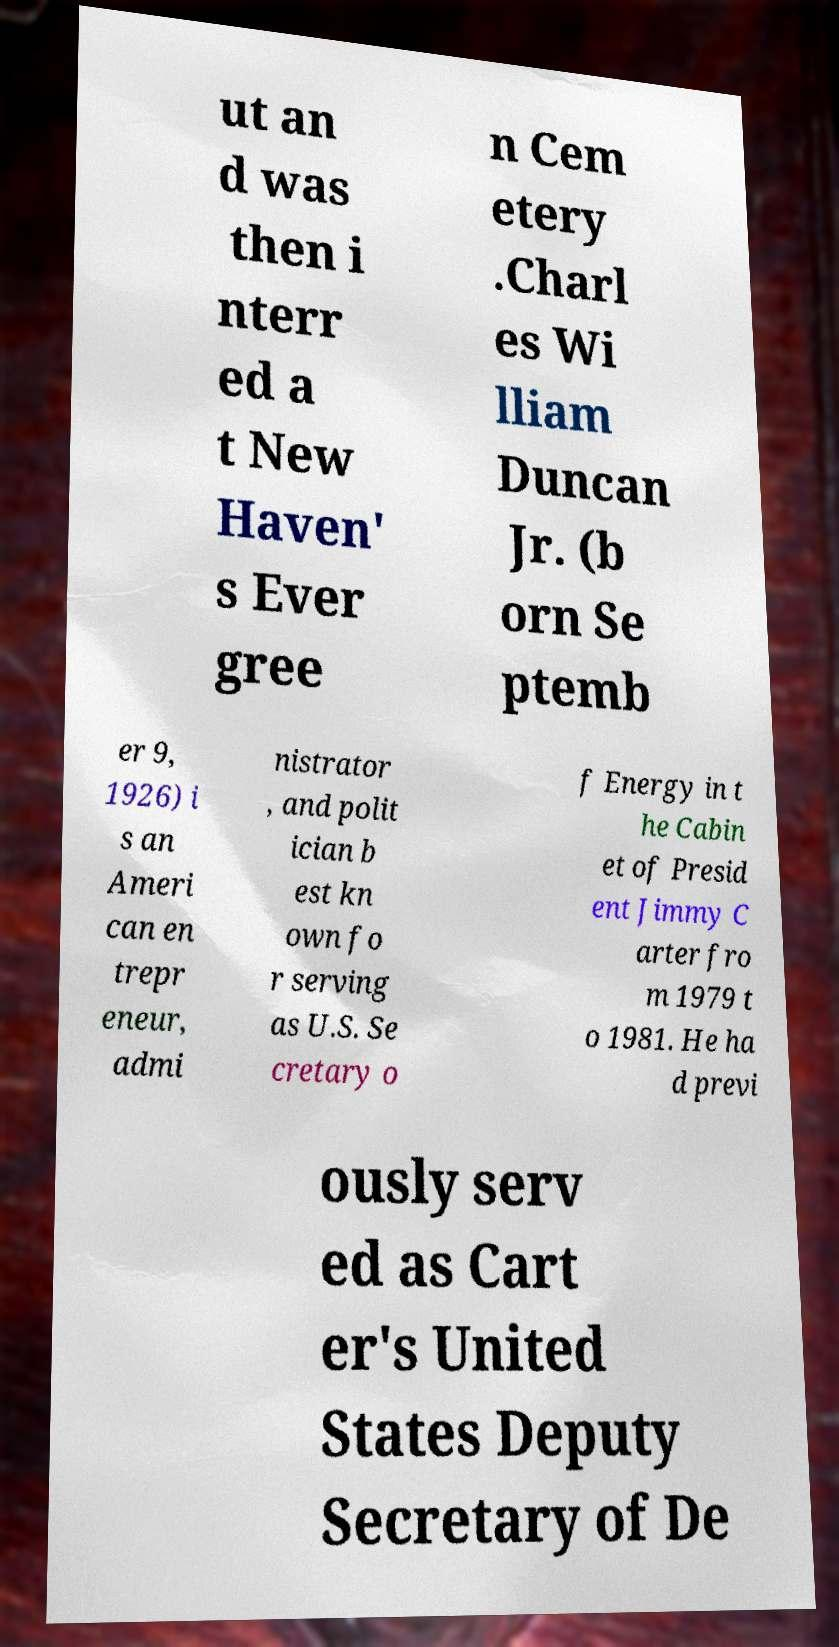I need the written content from this picture converted into text. Can you do that? ut an d was then i nterr ed a t New Haven' s Ever gree n Cem etery .Charl es Wi lliam Duncan Jr. (b orn Se ptemb er 9, 1926) i s an Ameri can en trepr eneur, admi nistrator , and polit ician b est kn own fo r serving as U.S. Se cretary o f Energy in t he Cabin et of Presid ent Jimmy C arter fro m 1979 t o 1981. He ha d previ ously serv ed as Cart er's United States Deputy Secretary of De 